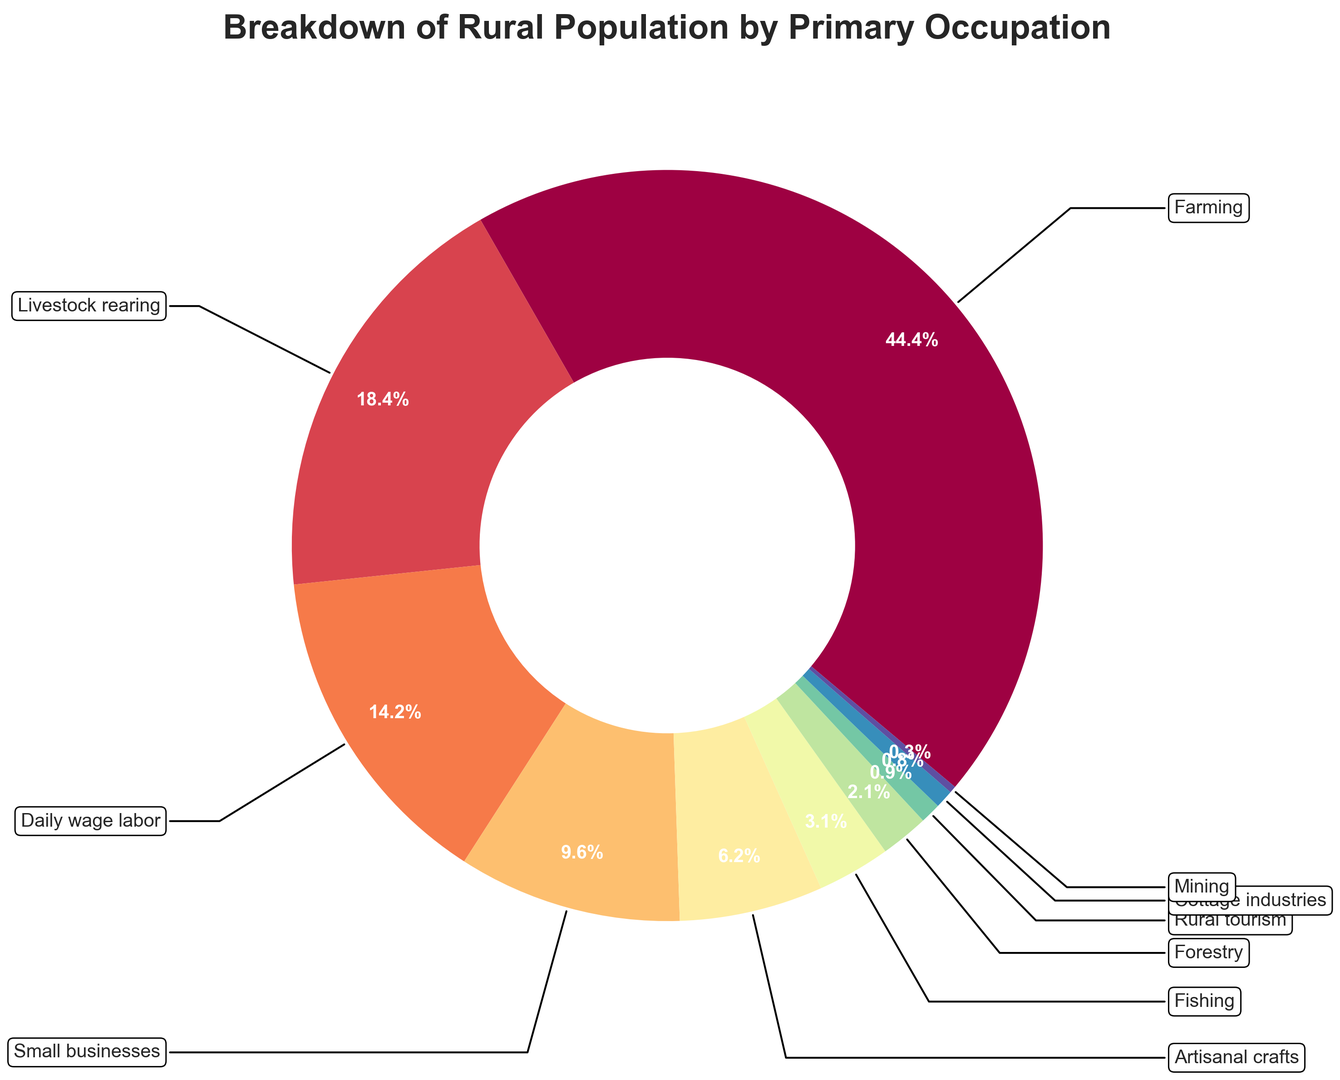Which occupation has the largest percentage of the rural population? The figure displays a ring chart where each segment represents an occupation, and the size of the segment is proportional to the population percentage. Farming occupies the largest segment.
Answer: Farming What is the combined percentage of people engaged in artisanal crafts and cottage industries? Artisanal crafts occupy 6.3% and cottage industries occupy 0.8%. Summing these gives 6.3% + 0.8% = 7.1%.
Answer: 7.1% Which two occupations have the smallest representation in the rural population? The smallest segments in the ring chart represent mining and cottage industries, each having 0.3% and 0.8% respectively.
Answer: Mining and Cottage industries Is the percentage of daily wage laborers greater than the combined percentage of those in forestry and rural tourism? Daily wage labor represents 14.5%. Forestry and rural tourism represent 2.1% and 0.9%, respectively. Summing them gives 2.1% + 0.9% = 3%, which is less than 14.5%.
Answer: Yes Among farming, livestock rearing, and small businesses, which has the highest percentage? Referencing the ring chart, farming has the highest percentage at 45.2%, followed by livestock rearing at 18.7%, and small businesses at 9.8%.
Answer: Farming How much more significant is the percentage of those engaged in livestock rearing compared to fishing? Livestock rearing represents 18.7%, while fishing represents 3.2%. The difference is 18.7% - 3.2% = 15.5%.
Answer: 15.5% What is the total percentage of the population engaged in primary occupations outside of farming? Subtract farming's percentage from 100%: 100% - 45.2% = 54.8%.
Answer: 54.8% Which segment is larger: daily wage labor or small businesses? Daily wage labor has a segment of 14.5%, whereas small businesses have 9.8%. Thus, the daily wage labor segment is larger.
Answer: Daily wage labor Is the combined percentage of people working in forestry and mining less than 5%? Forestry accounts for 2.1% and mining for 0.3%. Combined, they are 2.1% + 0.3% = 2.4%, which is less than 5%.
Answer: Yes What visual attribute indicates the segment for farming in the chart? The segment for farming is the largest, occupies the most significant portion of the ring chart, and is positioned as the first category starting the pie from the top-left (or startangle-positioned area).
Answer: Largest segment 